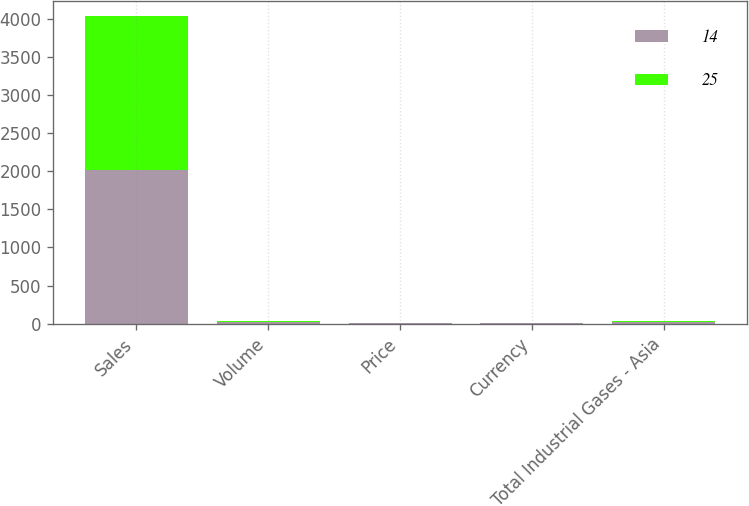Convert chart to OTSL. <chart><loc_0><loc_0><loc_500><loc_500><stacked_bar_chart><ecel><fcel>Sales<fcel>Volume<fcel>Price<fcel>Currency<fcel>Total Industrial Gases - Asia<nl><fcel>14<fcel>2018<fcel>17<fcel>4<fcel>4<fcel>25<nl><fcel>25<fcel>2017<fcel>14<fcel>1<fcel>1<fcel>14<nl></chart> 